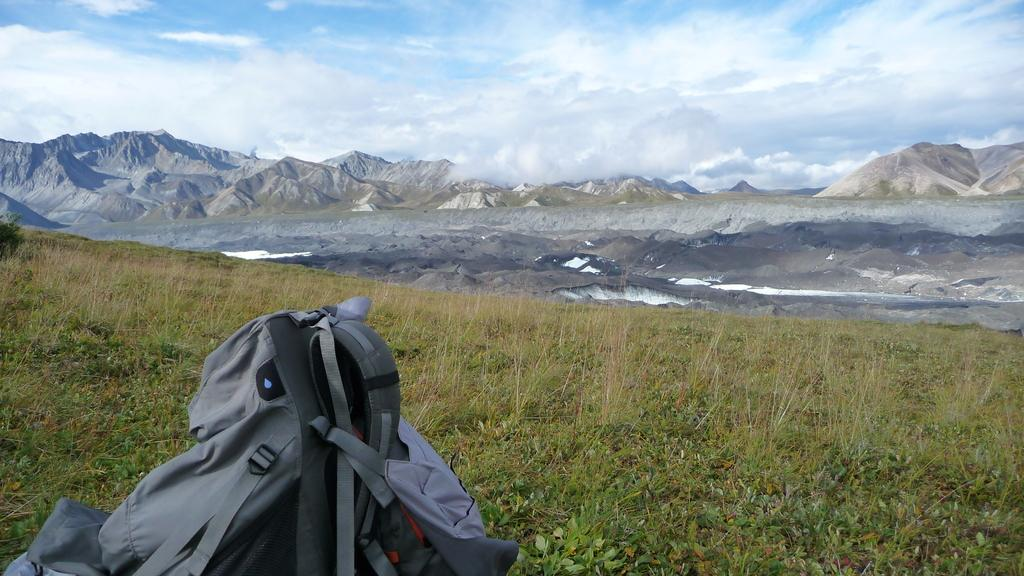What object is located at the bottom of the image? There is a bag at the bottom of the image. What type of vegetation is present in the image? There are plants in the image. What geographical feature can be seen in the middle of the image? There are hills in the middle of the image. What is visible at the top of the image? The sky is visible at the top of the image. How does the parcel get blown away in the image? There is no parcel present in the image, so it cannot be blown away. What type of lunch is being served in the image? There is no lunch being served in the image; the focus is on the bag, plants, hills, and sky. 